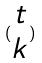<formula> <loc_0><loc_0><loc_500><loc_500>( \begin{matrix} t \\ k \end{matrix} )</formula> 